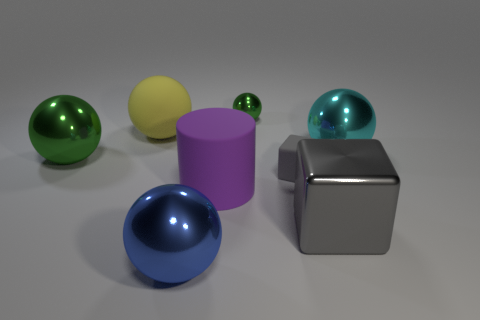How many objects are there in total in the image? There are five objects shown in the image, including a variety of spheres and geometric shapes. 